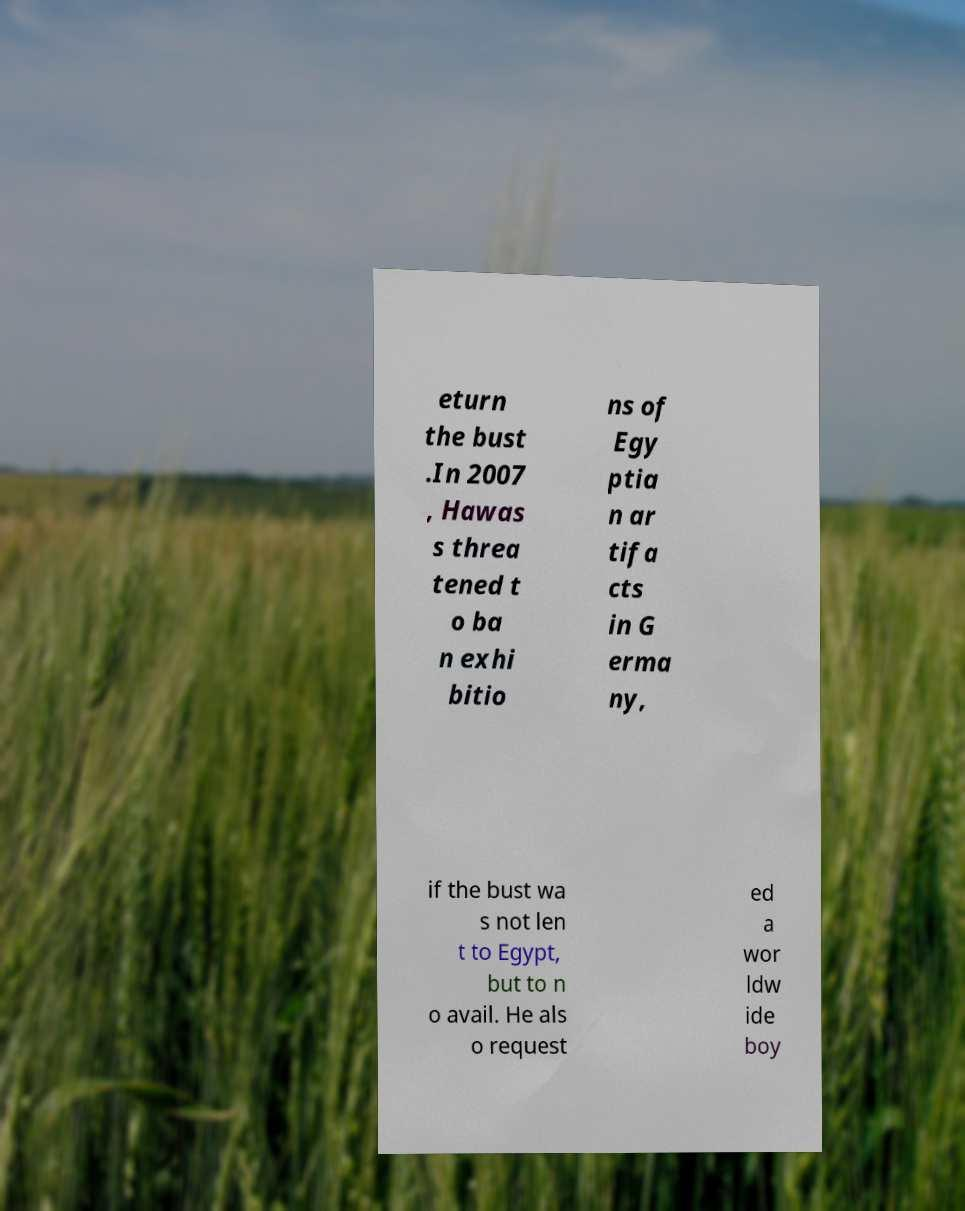What messages or text are displayed in this image? I need them in a readable, typed format. eturn the bust .In 2007 , Hawas s threa tened t o ba n exhi bitio ns of Egy ptia n ar tifa cts in G erma ny, if the bust wa s not len t to Egypt, but to n o avail. He als o request ed a wor ldw ide boy 